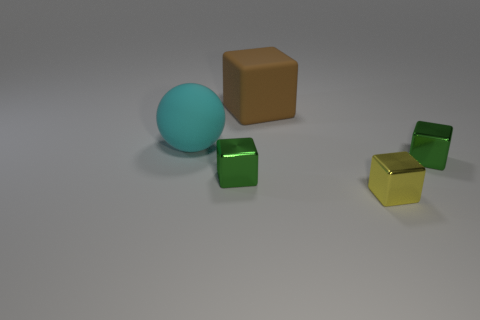Are there fewer matte cubes than tiny metallic objects?
Offer a terse response. Yes. What is the color of the tiny metallic object that is to the right of the yellow thing?
Your response must be concise. Green. There is a object that is on the right side of the rubber ball and on the left side of the large brown matte block; what material is it?
Offer a very short reply. Metal. There is a large thing that is made of the same material as the large block; what shape is it?
Offer a terse response. Sphere. There is a large matte thing right of the large cyan rubber object; how many large matte balls are behind it?
Keep it short and to the point. 0. What number of things are both left of the small yellow cube and to the right of the ball?
Your answer should be very brief. 2. What number of other objects are the same material as the ball?
Provide a succinct answer. 1. What is the color of the small block behind the tiny green metallic block that is left of the matte cube?
Make the answer very short. Green. There is a block behind the rubber ball; does it have the same color as the matte sphere?
Ensure brevity in your answer.  No. Is the brown rubber block the same size as the yellow object?
Ensure brevity in your answer.  No. 